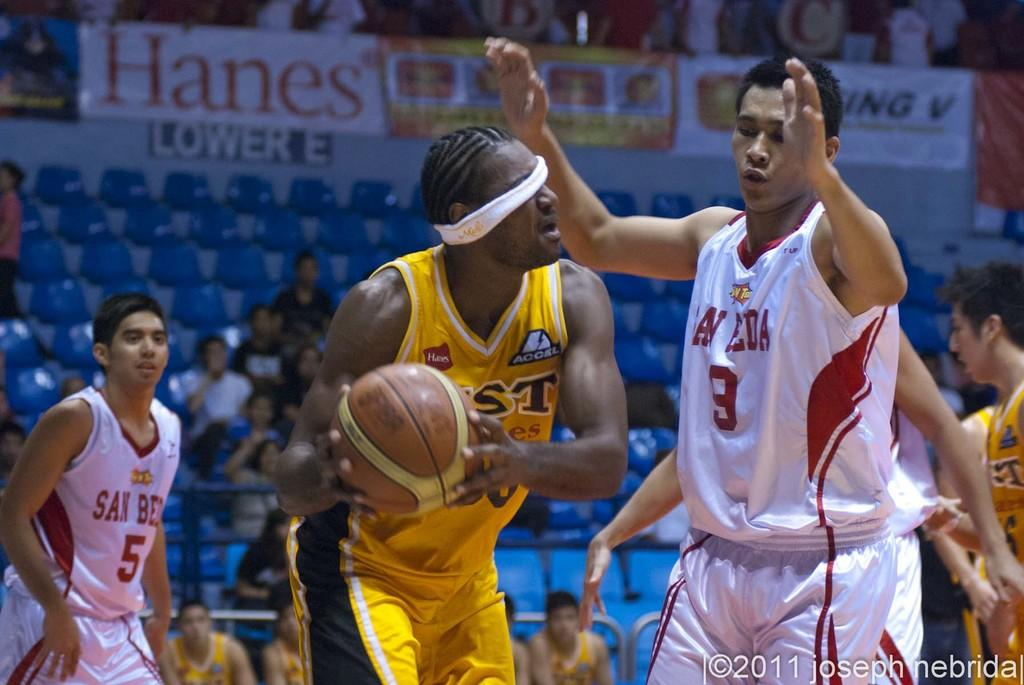<image>
Share a concise interpretation of the image provided. basketball game with palyers in white for san beda going against team in yellow with a banner for hanes above section lower e 